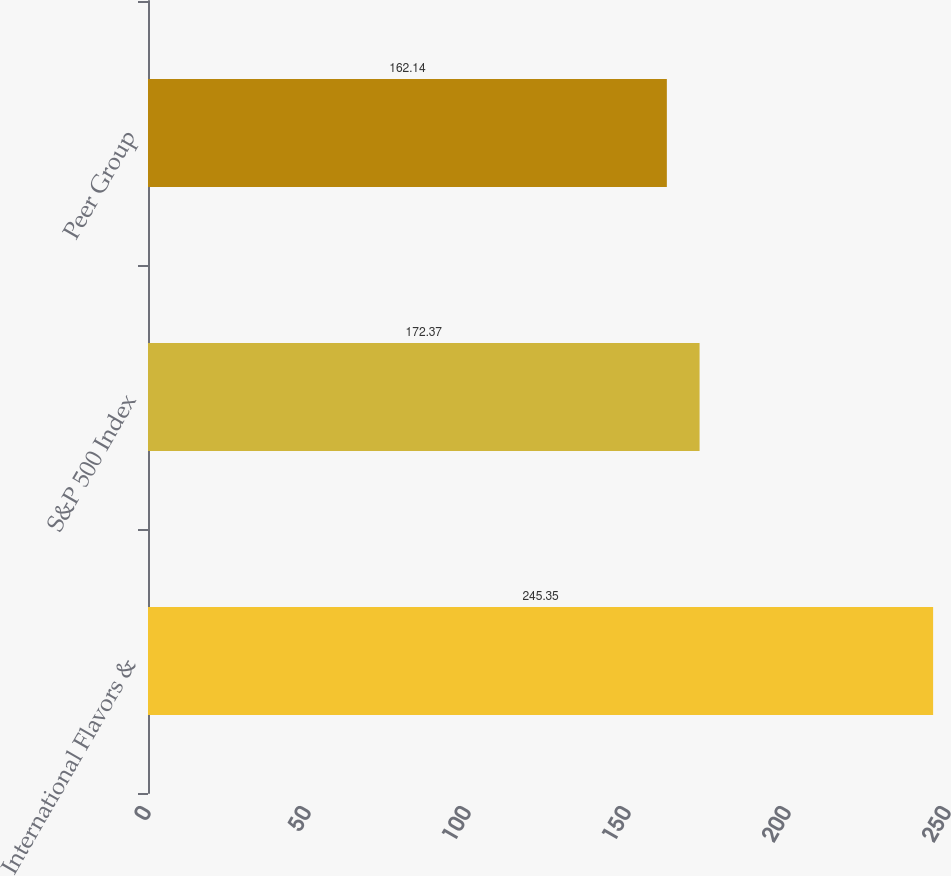Convert chart. <chart><loc_0><loc_0><loc_500><loc_500><bar_chart><fcel>International Flavors &<fcel>S&P 500 Index<fcel>Peer Group<nl><fcel>245.35<fcel>172.37<fcel>162.14<nl></chart> 